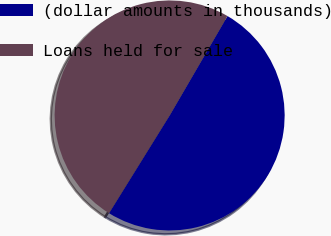Convert chart to OTSL. <chart><loc_0><loc_0><loc_500><loc_500><pie_chart><fcel>(dollar amounts in thousands)<fcel>Loans held for sale<nl><fcel>50.45%<fcel>49.55%<nl></chart> 